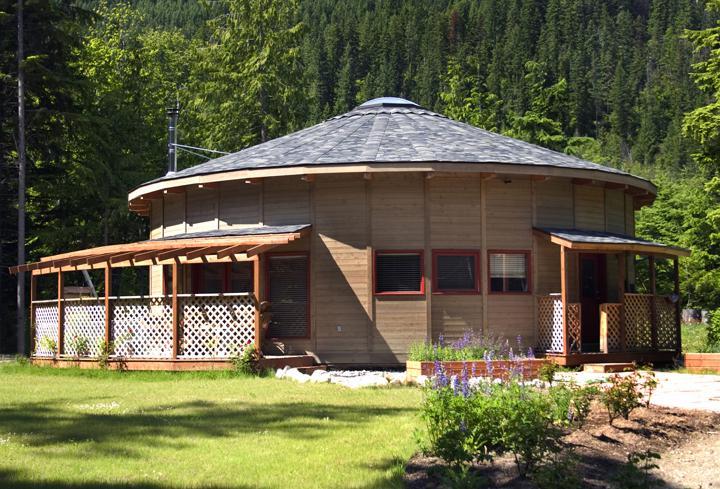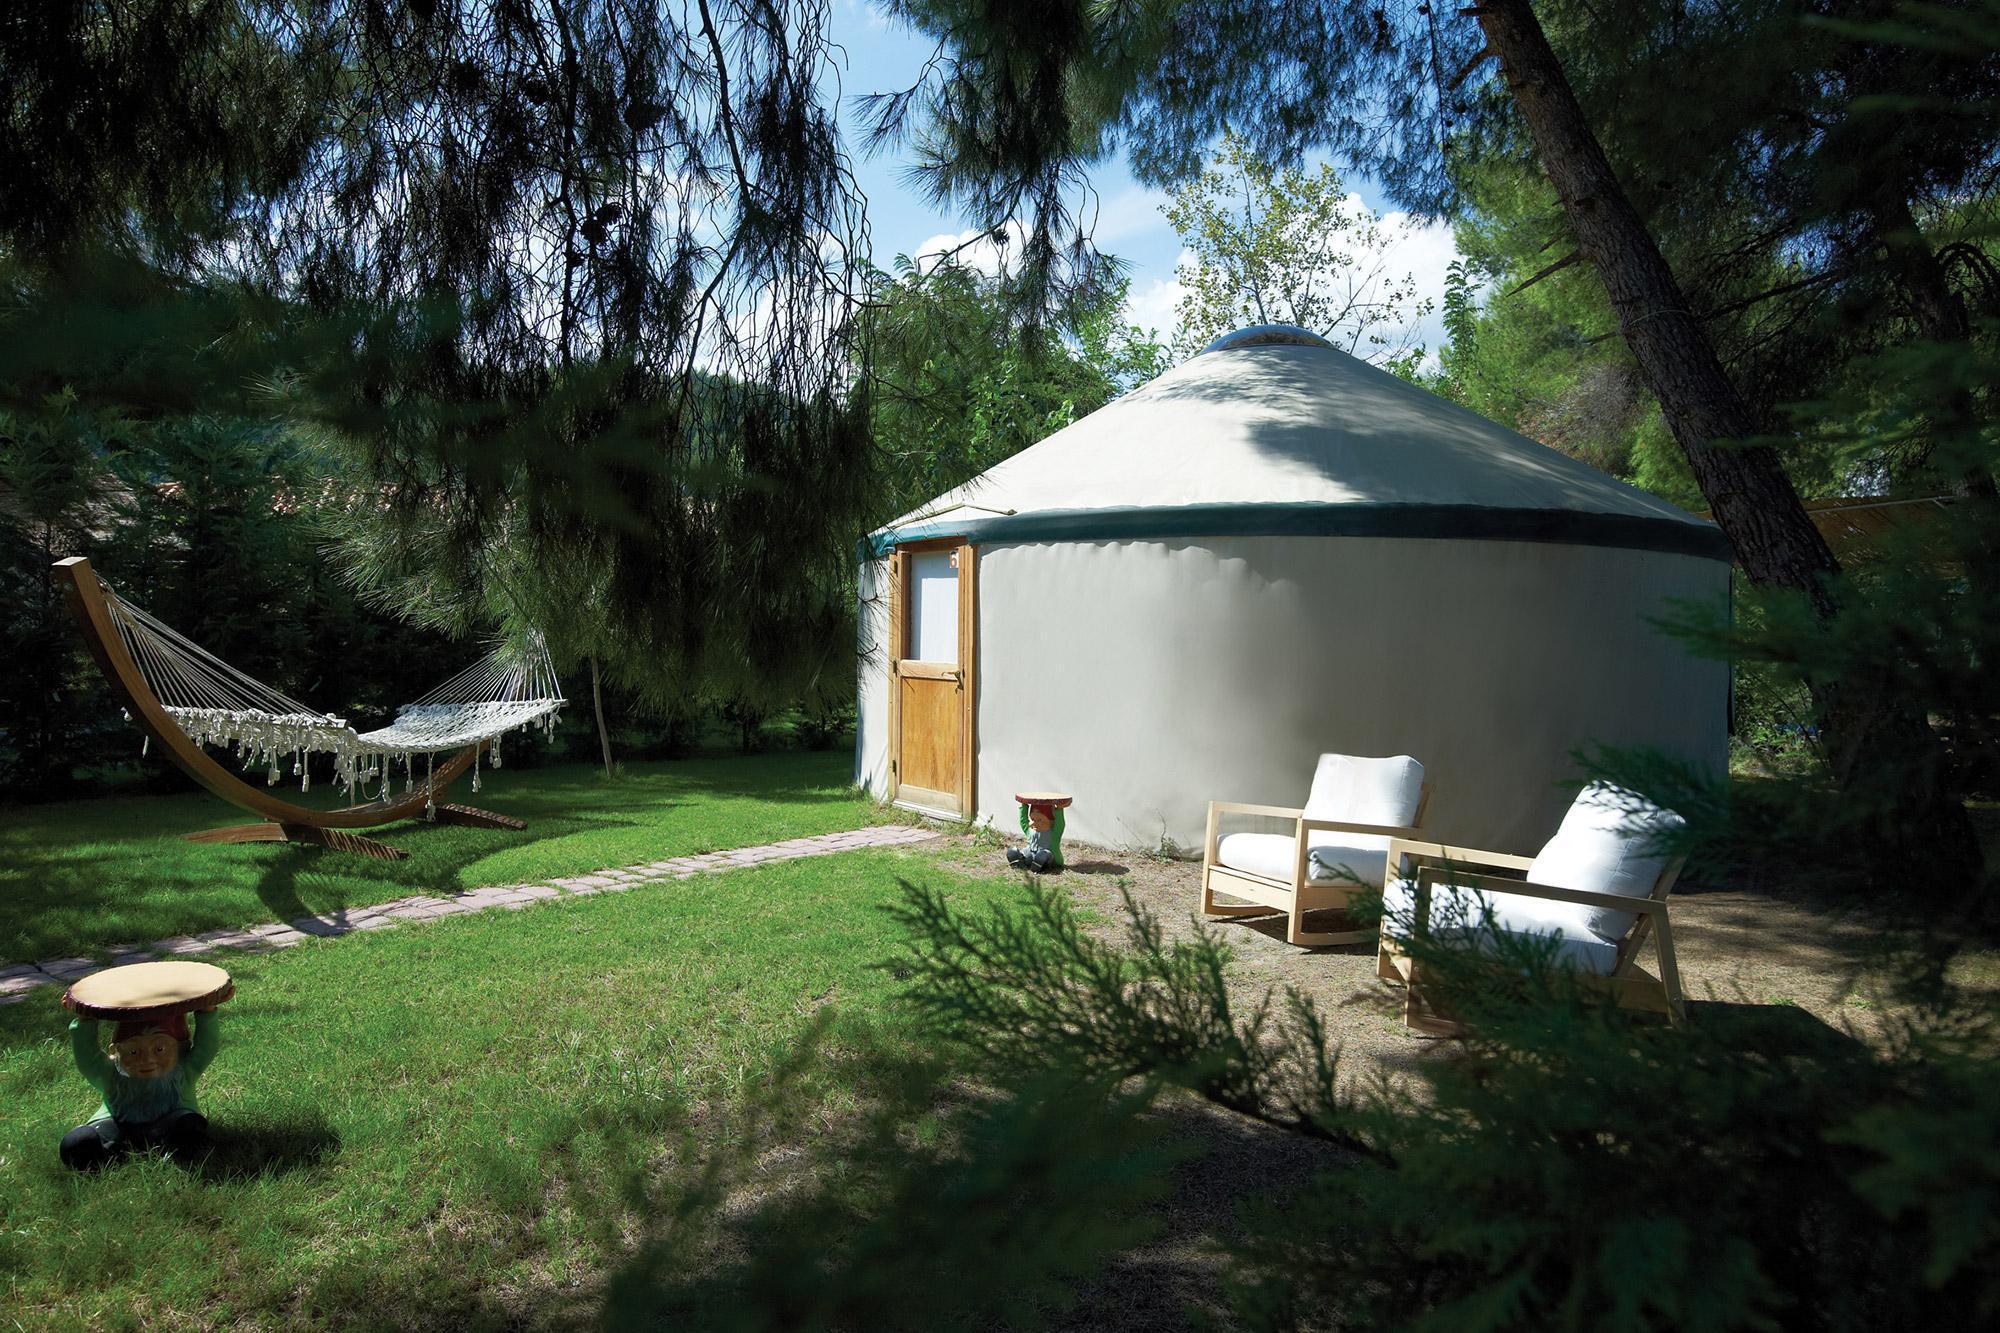The first image is the image on the left, the second image is the image on the right. Analyze the images presented: Is the assertion "A raised ramp surrounds the hut in the image on the left." valid? Answer yes or no. No. The first image is the image on the left, the second image is the image on the right. Considering the images on both sides, is "In one image, a yurt with similar colored walls and ceiling with a dark rim where the roof connects, has a door, but no windows." valid? Answer yes or no. Yes. 